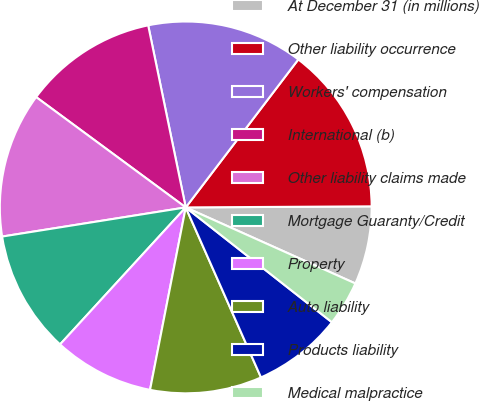Convert chart. <chart><loc_0><loc_0><loc_500><loc_500><pie_chart><fcel>At December 31 (in millions)<fcel>Other liability occurrence<fcel>Workers' compensation<fcel>International (b)<fcel>Other liability claims made<fcel>Mortgage Guaranty/Credit<fcel>Property<fcel>Auto liability<fcel>Products liability<fcel>Medical malpractice<nl><fcel>6.8%<fcel>14.56%<fcel>13.59%<fcel>11.65%<fcel>12.62%<fcel>10.68%<fcel>8.74%<fcel>9.71%<fcel>7.77%<fcel>3.89%<nl></chart> 